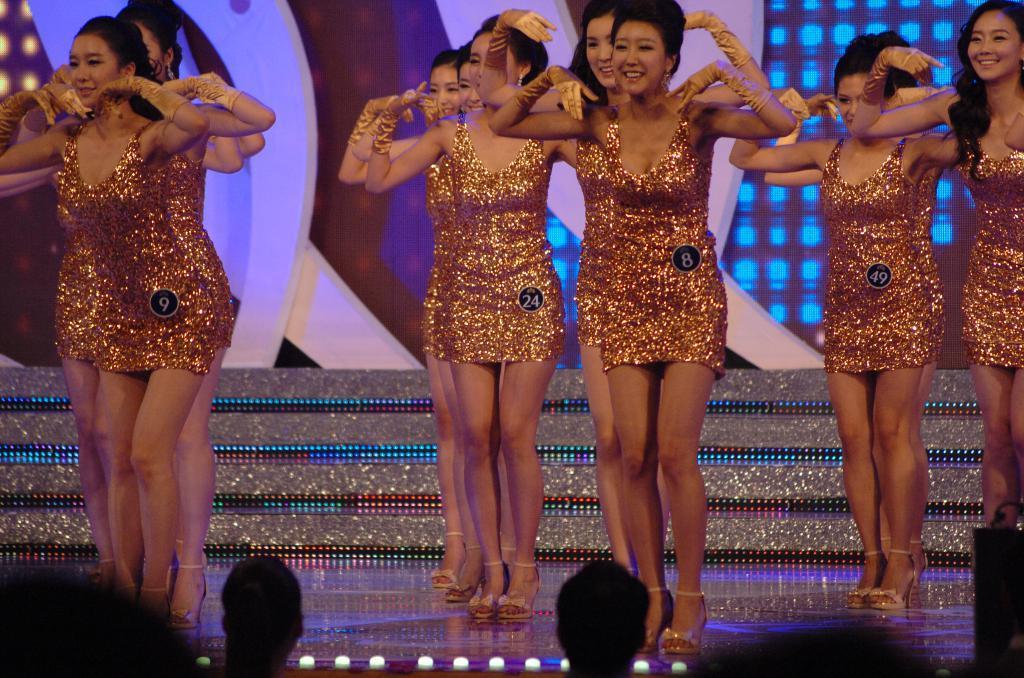Please provide a concise description of this image. In this image I can see few people are standing and wearing gold color dresses and they are on the stage. I can see the colorful background. In front I can see two people. 